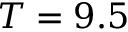Convert formula to latex. <formula><loc_0><loc_0><loc_500><loc_500>T = 9 . 5</formula> 